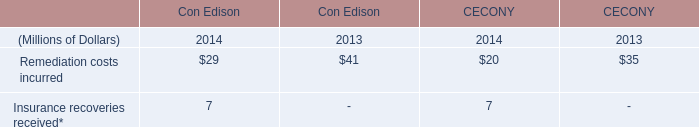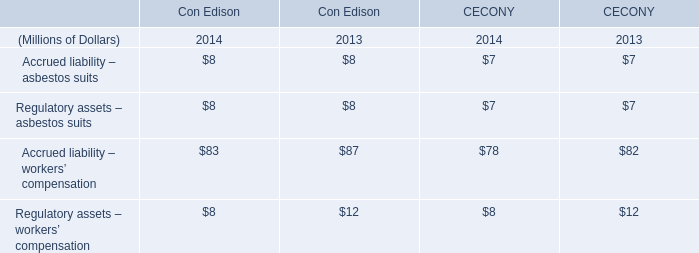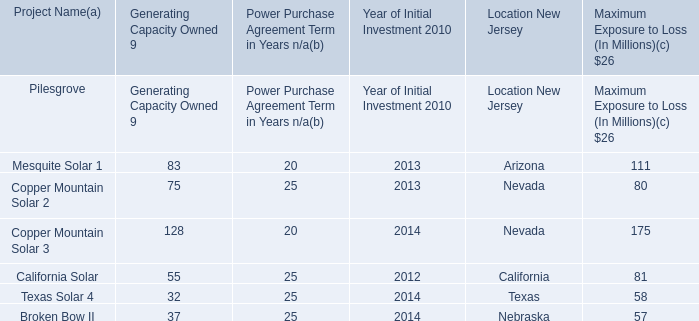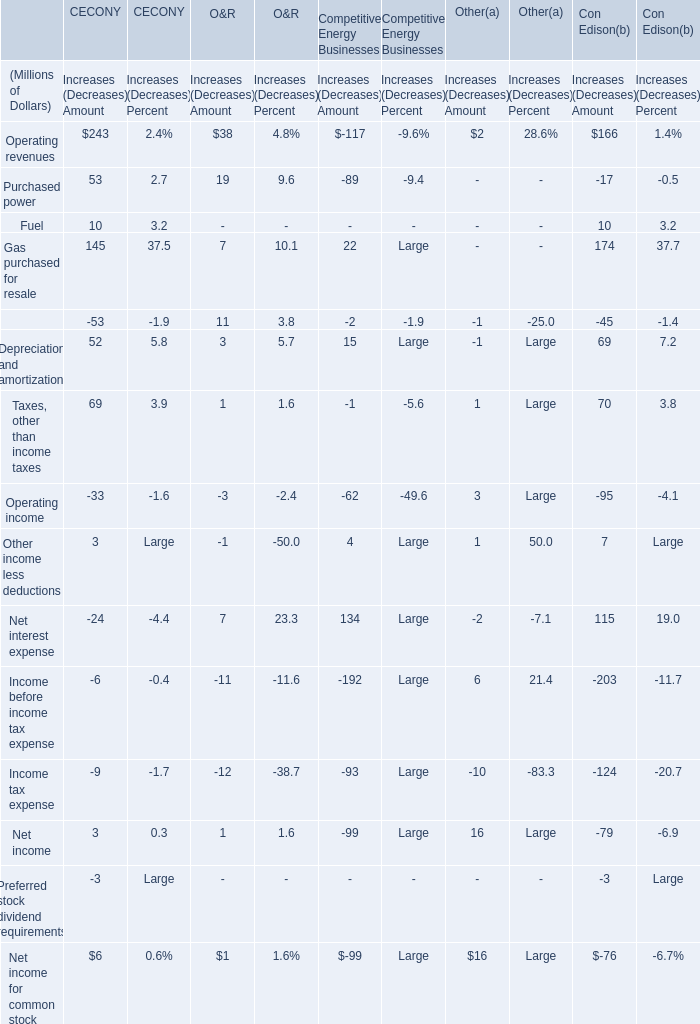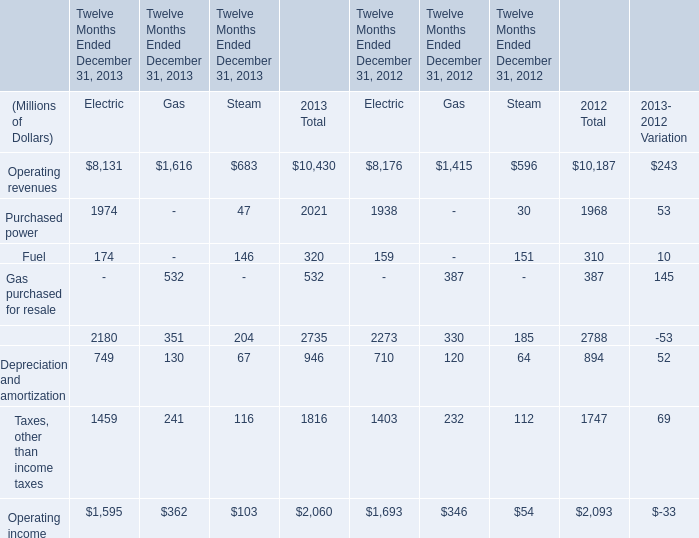Which year is operating revenues of gas the highest? 
Answer: 2013. 